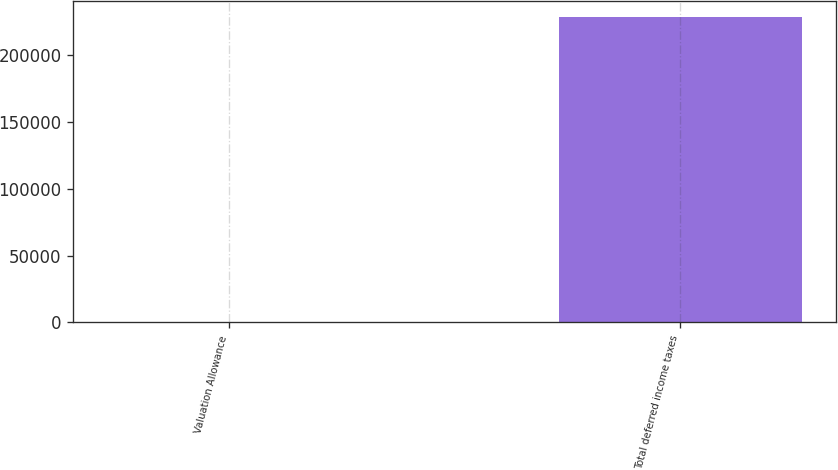Convert chart. <chart><loc_0><loc_0><loc_500><loc_500><bar_chart><fcel>Valuation Allowance<fcel>Total deferred income taxes<nl><fcel>2.36<fcel>228763<nl></chart> 